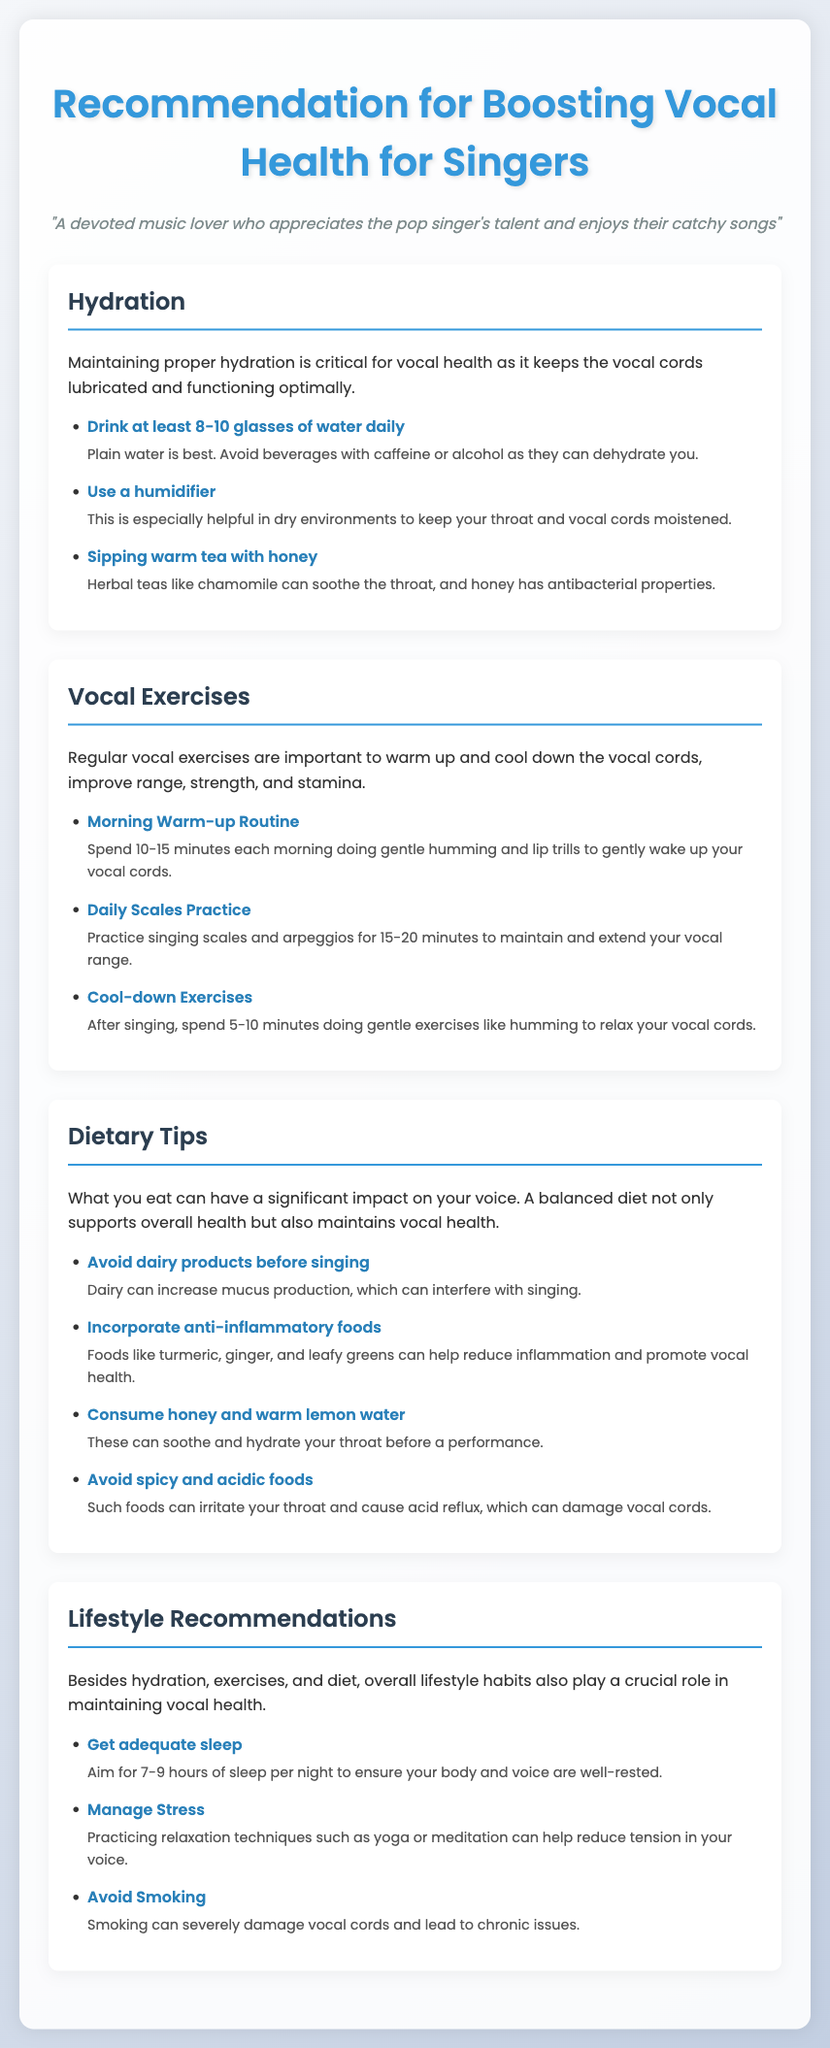what is the recommended daily water intake for vocal health? The document states that singers should drink at least 8-10 glasses of water daily to maintain proper hydration for vocal health.
Answer: 8-10 glasses what should be used in dry environments to help maintain vocal health? The document recommends using a humidifier in dry environments to keep the throat and vocal cords moistened.
Answer: Humidifier how long should a morning warm-up routine for singers last? It suggests that a morning warm-up routine should last 10-15 minutes to gently wake up the vocal cords.
Answer: 10-15 minutes name an anti-inflammatory food mentioned in the dietary tips. The document lists turmeric as an anti-inflammatory food that can help reduce inflammation and promote vocal health.
Answer: Turmeric what lifestyle habit is recommended to help reduce stress on the voice? The document mentions practicing relaxation techniques such as yoga or meditation to manage stress, which can help reduce tension in the voice.
Answer: Yoga or meditation how many hours of sleep should singers aim for each night? The document states that singers should aim for 7-9 hours of sleep per night to ensure their body and voice are well-rested.
Answer: 7-9 hours what type of beverages should be avoided for vocal health? The document advises avoiding beverages with caffeine or alcohol as they can dehydrate the vocal cords.
Answer: Caffeine or alcohol which food is suggested to be consumed before a performance for soothing the throat? The document suggests consuming honey and warm lemon water to soothe and hydrate the throat before a performance.
Answer: Honey and warm lemon water 